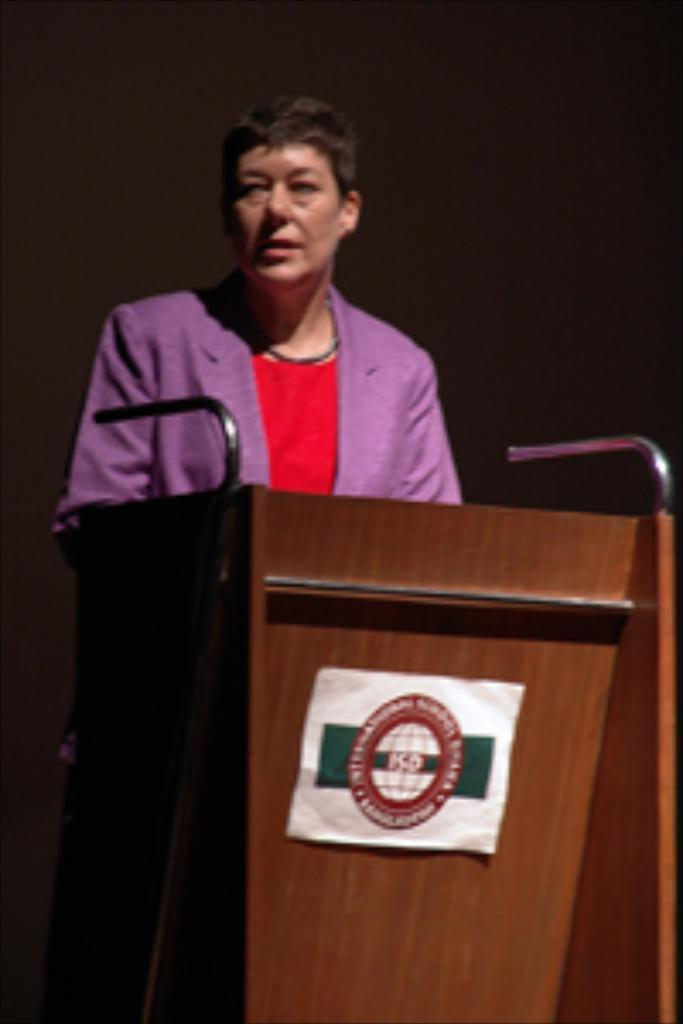What is the main subject of the image? There is a person standing in the center of the image. What is the person standing in front of? The person is in front of a podium. What can be seen in the background of the image? There is a wall in the background of the image. How many screws can be seen on the person's shirt in the image? There are no screws visible on the person's shirt in the image. What type of roll is being used by the person in the image? There is no roll present in the image; the person is standing in front of a podium. 